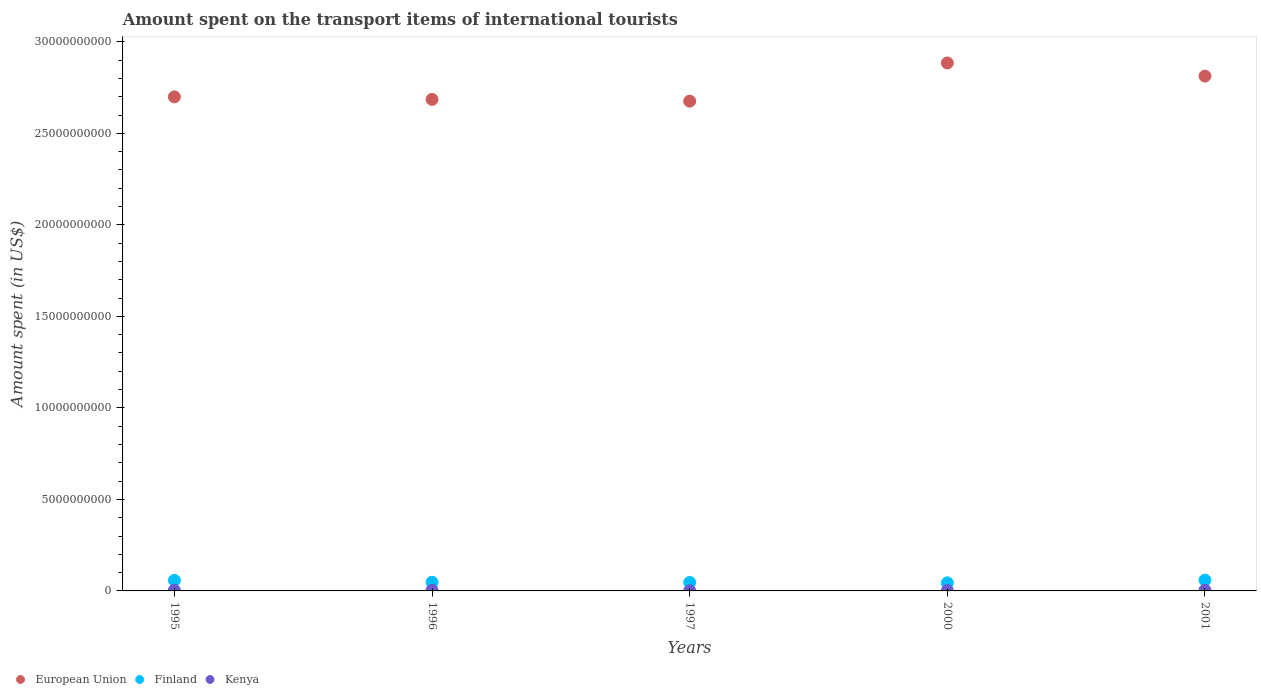How many different coloured dotlines are there?
Make the answer very short. 3. What is the amount spent on the transport items of international tourists in Kenya in 2000?
Offer a terse response. 2.40e+07. Across all years, what is the maximum amount spent on the transport items of international tourists in European Union?
Your answer should be compact. 2.88e+1. Across all years, what is the minimum amount spent on the transport items of international tourists in European Union?
Ensure brevity in your answer.  2.68e+1. In which year was the amount spent on the transport items of international tourists in European Union maximum?
Your answer should be compact. 2000. What is the total amount spent on the transport items of international tourists in Finland in the graph?
Offer a terse response. 2.54e+09. What is the difference between the amount spent on the transport items of international tourists in European Union in 1996 and that in 2000?
Provide a succinct answer. -1.99e+09. What is the difference between the amount spent on the transport items of international tourists in Kenya in 2000 and the amount spent on the transport items of international tourists in European Union in 1996?
Offer a terse response. -2.68e+1. What is the average amount spent on the transport items of international tourists in Kenya per year?
Make the answer very short. 2.90e+07. In the year 1997, what is the difference between the amount spent on the transport items of international tourists in Finland and amount spent on the transport items of international tourists in Kenya?
Provide a succinct answer. 4.54e+08. In how many years, is the amount spent on the transport items of international tourists in Finland greater than 5000000000 US$?
Give a very brief answer. 0. What is the ratio of the amount spent on the transport items of international tourists in Kenya in 1996 to that in 1997?
Offer a terse response. 5.14. Is the difference between the amount spent on the transport items of international tourists in Finland in 1996 and 2001 greater than the difference between the amount spent on the transport items of international tourists in Kenya in 1996 and 2001?
Your answer should be compact. No. What is the difference between the highest and the second highest amount spent on the transport items of international tourists in Finland?
Make the answer very short. 1.50e+07. What is the difference between the highest and the lowest amount spent on the transport items of international tourists in Finland?
Offer a very short reply. 1.49e+08. In how many years, is the amount spent on the transport items of international tourists in European Union greater than the average amount spent on the transport items of international tourists in European Union taken over all years?
Keep it short and to the point. 2. Is the sum of the amount spent on the transport items of international tourists in Kenya in 1996 and 2000 greater than the maximum amount spent on the transport items of international tourists in European Union across all years?
Give a very brief answer. No. Does the graph contain any zero values?
Offer a very short reply. No. What is the title of the graph?
Offer a terse response. Amount spent on the transport items of international tourists. Does "Ghana" appear as one of the legend labels in the graph?
Your answer should be compact. No. What is the label or title of the X-axis?
Your answer should be compact. Years. What is the label or title of the Y-axis?
Provide a succinct answer. Amount spent (in US$). What is the Amount spent (in US$) of European Union in 1995?
Make the answer very short. 2.70e+1. What is the Amount spent (in US$) in Finland in 1995?
Your answer should be compact. 5.75e+08. What is the Amount spent (in US$) in Kenya in 1995?
Your response must be concise. 3.80e+07. What is the Amount spent (in US$) in European Union in 1996?
Your answer should be very brief. 2.69e+1. What is the Amount spent (in US$) of Finland in 1996?
Your answer should be very brief. 4.75e+08. What is the Amount spent (in US$) in Kenya in 1996?
Keep it short and to the point. 3.60e+07. What is the Amount spent (in US$) in European Union in 1997?
Make the answer very short. 2.68e+1. What is the Amount spent (in US$) of Finland in 1997?
Provide a short and direct response. 4.61e+08. What is the Amount spent (in US$) of European Union in 2000?
Offer a very short reply. 2.88e+1. What is the Amount spent (in US$) of Finland in 2000?
Ensure brevity in your answer.  4.41e+08. What is the Amount spent (in US$) of Kenya in 2000?
Make the answer very short. 2.40e+07. What is the Amount spent (in US$) of European Union in 2001?
Your answer should be very brief. 2.81e+1. What is the Amount spent (in US$) of Finland in 2001?
Your answer should be very brief. 5.90e+08. What is the Amount spent (in US$) in Kenya in 2001?
Provide a succinct answer. 4.00e+07. Across all years, what is the maximum Amount spent (in US$) of European Union?
Your answer should be very brief. 2.88e+1. Across all years, what is the maximum Amount spent (in US$) in Finland?
Give a very brief answer. 5.90e+08. Across all years, what is the maximum Amount spent (in US$) in Kenya?
Ensure brevity in your answer.  4.00e+07. Across all years, what is the minimum Amount spent (in US$) of European Union?
Your response must be concise. 2.68e+1. Across all years, what is the minimum Amount spent (in US$) of Finland?
Provide a succinct answer. 4.41e+08. What is the total Amount spent (in US$) in European Union in the graph?
Provide a short and direct response. 1.38e+11. What is the total Amount spent (in US$) in Finland in the graph?
Provide a short and direct response. 2.54e+09. What is the total Amount spent (in US$) of Kenya in the graph?
Keep it short and to the point. 1.45e+08. What is the difference between the Amount spent (in US$) of European Union in 1995 and that in 1996?
Offer a terse response. 1.37e+08. What is the difference between the Amount spent (in US$) of Finland in 1995 and that in 1996?
Provide a short and direct response. 1.00e+08. What is the difference between the Amount spent (in US$) of European Union in 1995 and that in 1997?
Make the answer very short. 2.35e+08. What is the difference between the Amount spent (in US$) in Finland in 1995 and that in 1997?
Provide a succinct answer. 1.14e+08. What is the difference between the Amount spent (in US$) of Kenya in 1995 and that in 1997?
Your answer should be very brief. 3.10e+07. What is the difference between the Amount spent (in US$) in European Union in 1995 and that in 2000?
Provide a short and direct response. -1.85e+09. What is the difference between the Amount spent (in US$) of Finland in 1995 and that in 2000?
Make the answer very short. 1.34e+08. What is the difference between the Amount spent (in US$) of Kenya in 1995 and that in 2000?
Provide a short and direct response. 1.40e+07. What is the difference between the Amount spent (in US$) of European Union in 1995 and that in 2001?
Give a very brief answer. -1.13e+09. What is the difference between the Amount spent (in US$) of Finland in 1995 and that in 2001?
Provide a short and direct response. -1.50e+07. What is the difference between the Amount spent (in US$) of Kenya in 1995 and that in 2001?
Keep it short and to the point. -2.00e+06. What is the difference between the Amount spent (in US$) of European Union in 1996 and that in 1997?
Provide a succinct answer. 9.81e+07. What is the difference between the Amount spent (in US$) of Finland in 1996 and that in 1997?
Provide a succinct answer. 1.40e+07. What is the difference between the Amount spent (in US$) of Kenya in 1996 and that in 1997?
Your answer should be very brief. 2.90e+07. What is the difference between the Amount spent (in US$) in European Union in 1996 and that in 2000?
Your answer should be very brief. -1.99e+09. What is the difference between the Amount spent (in US$) of Finland in 1996 and that in 2000?
Your answer should be very brief. 3.40e+07. What is the difference between the Amount spent (in US$) in European Union in 1996 and that in 2001?
Provide a succinct answer. -1.27e+09. What is the difference between the Amount spent (in US$) in Finland in 1996 and that in 2001?
Provide a succinct answer. -1.15e+08. What is the difference between the Amount spent (in US$) in Kenya in 1996 and that in 2001?
Provide a succinct answer. -4.00e+06. What is the difference between the Amount spent (in US$) of European Union in 1997 and that in 2000?
Offer a terse response. -2.09e+09. What is the difference between the Amount spent (in US$) of Kenya in 1997 and that in 2000?
Offer a terse response. -1.70e+07. What is the difference between the Amount spent (in US$) in European Union in 1997 and that in 2001?
Offer a terse response. -1.37e+09. What is the difference between the Amount spent (in US$) in Finland in 1997 and that in 2001?
Your answer should be compact. -1.29e+08. What is the difference between the Amount spent (in US$) in Kenya in 1997 and that in 2001?
Provide a short and direct response. -3.30e+07. What is the difference between the Amount spent (in US$) of European Union in 2000 and that in 2001?
Ensure brevity in your answer.  7.18e+08. What is the difference between the Amount spent (in US$) of Finland in 2000 and that in 2001?
Keep it short and to the point. -1.49e+08. What is the difference between the Amount spent (in US$) in Kenya in 2000 and that in 2001?
Make the answer very short. -1.60e+07. What is the difference between the Amount spent (in US$) of European Union in 1995 and the Amount spent (in US$) of Finland in 1996?
Your response must be concise. 2.65e+1. What is the difference between the Amount spent (in US$) of European Union in 1995 and the Amount spent (in US$) of Kenya in 1996?
Provide a succinct answer. 2.70e+1. What is the difference between the Amount spent (in US$) in Finland in 1995 and the Amount spent (in US$) in Kenya in 1996?
Offer a terse response. 5.39e+08. What is the difference between the Amount spent (in US$) of European Union in 1995 and the Amount spent (in US$) of Finland in 1997?
Make the answer very short. 2.65e+1. What is the difference between the Amount spent (in US$) in European Union in 1995 and the Amount spent (in US$) in Kenya in 1997?
Your answer should be compact. 2.70e+1. What is the difference between the Amount spent (in US$) of Finland in 1995 and the Amount spent (in US$) of Kenya in 1997?
Keep it short and to the point. 5.68e+08. What is the difference between the Amount spent (in US$) in European Union in 1995 and the Amount spent (in US$) in Finland in 2000?
Give a very brief answer. 2.66e+1. What is the difference between the Amount spent (in US$) of European Union in 1995 and the Amount spent (in US$) of Kenya in 2000?
Give a very brief answer. 2.70e+1. What is the difference between the Amount spent (in US$) in Finland in 1995 and the Amount spent (in US$) in Kenya in 2000?
Your answer should be very brief. 5.51e+08. What is the difference between the Amount spent (in US$) in European Union in 1995 and the Amount spent (in US$) in Finland in 2001?
Keep it short and to the point. 2.64e+1. What is the difference between the Amount spent (in US$) of European Union in 1995 and the Amount spent (in US$) of Kenya in 2001?
Provide a succinct answer. 2.70e+1. What is the difference between the Amount spent (in US$) of Finland in 1995 and the Amount spent (in US$) of Kenya in 2001?
Make the answer very short. 5.35e+08. What is the difference between the Amount spent (in US$) in European Union in 1996 and the Amount spent (in US$) in Finland in 1997?
Make the answer very short. 2.64e+1. What is the difference between the Amount spent (in US$) of European Union in 1996 and the Amount spent (in US$) of Kenya in 1997?
Offer a terse response. 2.68e+1. What is the difference between the Amount spent (in US$) in Finland in 1996 and the Amount spent (in US$) in Kenya in 1997?
Provide a short and direct response. 4.68e+08. What is the difference between the Amount spent (in US$) in European Union in 1996 and the Amount spent (in US$) in Finland in 2000?
Offer a very short reply. 2.64e+1. What is the difference between the Amount spent (in US$) in European Union in 1996 and the Amount spent (in US$) in Kenya in 2000?
Keep it short and to the point. 2.68e+1. What is the difference between the Amount spent (in US$) in Finland in 1996 and the Amount spent (in US$) in Kenya in 2000?
Offer a terse response. 4.51e+08. What is the difference between the Amount spent (in US$) in European Union in 1996 and the Amount spent (in US$) in Finland in 2001?
Give a very brief answer. 2.63e+1. What is the difference between the Amount spent (in US$) in European Union in 1996 and the Amount spent (in US$) in Kenya in 2001?
Your response must be concise. 2.68e+1. What is the difference between the Amount spent (in US$) in Finland in 1996 and the Amount spent (in US$) in Kenya in 2001?
Your answer should be compact. 4.35e+08. What is the difference between the Amount spent (in US$) of European Union in 1997 and the Amount spent (in US$) of Finland in 2000?
Your answer should be compact. 2.63e+1. What is the difference between the Amount spent (in US$) in European Union in 1997 and the Amount spent (in US$) in Kenya in 2000?
Offer a terse response. 2.67e+1. What is the difference between the Amount spent (in US$) of Finland in 1997 and the Amount spent (in US$) of Kenya in 2000?
Ensure brevity in your answer.  4.37e+08. What is the difference between the Amount spent (in US$) of European Union in 1997 and the Amount spent (in US$) of Finland in 2001?
Your response must be concise. 2.62e+1. What is the difference between the Amount spent (in US$) in European Union in 1997 and the Amount spent (in US$) in Kenya in 2001?
Provide a short and direct response. 2.67e+1. What is the difference between the Amount spent (in US$) of Finland in 1997 and the Amount spent (in US$) of Kenya in 2001?
Offer a very short reply. 4.21e+08. What is the difference between the Amount spent (in US$) in European Union in 2000 and the Amount spent (in US$) in Finland in 2001?
Ensure brevity in your answer.  2.83e+1. What is the difference between the Amount spent (in US$) in European Union in 2000 and the Amount spent (in US$) in Kenya in 2001?
Offer a terse response. 2.88e+1. What is the difference between the Amount spent (in US$) in Finland in 2000 and the Amount spent (in US$) in Kenya in 2001?
Offer a very short reply. 4.01e+08. What is the average Amount spent (in US$) in European Union per year?
Provide a succinct answer. 2.75e+1. What is the average Amount spent (in US$) in Finland per year?
Give a very brief answer. 5.08e+08. What is the average Amount spent (in US$) in Kenya per year?
Provide a short and direct response. 2.90e+07. In the year 1995, what is the difference between the Amount spent (in US$) in European Union and Amount spent (in US$) in Finland?
Give a very brief answer. 2.64e+1. In the year 1995, what is the difference between the Amount spent (in US$) of European Union and Amount spent (in US$) of Kenya?
Provide a short and direct response. 2.70e+1. In the year 1995, what is the difference between the Amount spent (in US$) of Finland and Amount spent (in US$) of Kenya?
Give a very brief answer. 5.37e+08. In the year 1996, what is the difference between the Amount spent (in US$) in European Union and Amount spent (in US$) in Finland?
Offer a terse response. 2.64e+1. In the year 1996, what is the difference between the Amount spent (in US$) of European Union and Amount spent (in US$) of Kenya?
Offer a very short reply. 2.68e+1. In the year 1996, what is the difference between the Amount spent (in US$) in Finland and Amount spent (in US$) in Kenya?
Offer a terse response. 4.39e+08. In the year 1997, what is the difference between the Amount spent (in US$) in European Union and Amount spent (in US$) in Finland?
Provide a short and direct response. 2.63e+1. In the year 1997, what is the difference between the Amount spent (in US$) in European Union and Amount spent (in US$) in Kenya?
Your response must be concise. 2.68e+1. In the year 1997, what is the difference between the Amount spent (in US$) in Finland and Amount spent (in US$) in Kenya?
Give a very brief answer. 4.54e+08. In the year 2000, what is the difference between the Amount spent (in US$) of European Union and Amount spent (in US$) of Finland?
Give a very brief answer. 2.84e+1. In the year 2000, what is the difference between the Amount spent (in US$) in European Union and Amount spent (in US$) in Kenya?
Your response must be concise. 2.88e+1. In the year 2000, what is the difference between the Amount spent (in US$) in Finland and Amount spent (in US$) in Kenya?
Keep it short and to the point. 4.17e+08. In the year 2001, what is the difference between the Amount spent (in US$) of European Union and Amount spent (in US$) of Finland?
Provide a short and direct response. 2.75e+1. In the year 2001, what is the difference between the Amount spent (in US$) in European Union and Amount spent (in US$) in Kenya?
Keep it short and to the point. 2.81e+1. In the year 2001, what is the difference between the Amount spent (in US$) of Finland and Amount spent (in US$) of Kenya?
Provide a succinct answer. 5.50e+08. What is the ratio of the Amount spent (in US$) of Finland in 1995 to that in 1996?
Ensure brevity in your answer.  1.21. What is the ratio of the Amount spent (in US$) of Kenya in 1995 to that in 1996?
Your response must be concise. 1.06. What is the ratio of the Amount spent (in US$) in European Union in 1995 to that in 1997?
Offer a terse response. 1.01. What is the ratio of the Amount spent (in US$) of Finland in 1995 to that in 1997?
Provide a succinct answer. 1.25. What is the ratio of the Amount spent (in US$) of Kenya in 1995 to that in 1997?
Provide a short and direct response. 5.43. What is the ratio of the Amount spent (in US$) of European Union in 1995 to that in 2000?
Ensure brevity in your answer.  0.94. What is the ratio of the Amount spent (in US$) of Finland in 1995 to that in 2000?
Ensure brevity in your answer.  1.3. What is the ratio of the Amount spent (in US$) in Kenya in 1995 to that in 2000?
Keep it short and to the point. 1.58. What is the ratio of the Amount spent (in US$) in European Union in 1995 to that in 2001?
Ensure brevity in your answer.  0.96. What is the ratio of the Amount spent (in US$) in Finland in 1995 to that in 2001?
Make the answer very short. 0.97. What is the ratio of the Amount spent (in US$) of Finland in 1996 to that in 1997?
Offer a very short reply. 1.03. What is the ratio of the Amount spent (in US$) in Kenya in 1996 to that in 1997?
Give a very brief answer. 5.14. What is the ratio of the Amount spent (in US$) of European Union in 1996 to that in 2000?
Offer a terse response. 0.93. What is the ratio of the Amount spent (in US$) of Finland in 1996 to that in 2000?
Keep it short and to the point. 1.08. What is the ratio of the Amount spent (in US$) in European Union in 1996 to that in 2001?
Keep it short and to the point. 0.95. What is the ratio of the Amount spent (in US$) in Finland in 1996 to that in 2001?
Provide a succinct answer. 0.81. What is the ratio of the Amount spent (in US$) of Kenya in 1996 to that in 2001?
Provide a succinct answer. 0.9. What is the ratio of the Amount spent (in US$) in European Union in 1997 to that in 2000?
Your response must be concise. 0.93. What is the ratio of the Amount spent (in US$) of Finland in 1997 to that in 2000?
Ensure brevity in your answer.  1.05. What is the ratio of the Amount spent (in US$) of Kenya in 1997 to that in 2000?
Offer a terse response. 0.29. What is the ratio of the Amount spent (in US$) in European Union in 1997 to that in 2001?
Make the answer very short. 0.95. What is the ratio of the Amount spent (in US$) of Finland in 1997 to that in 2001?
Provide a short and direct response. 0.78. What is the ratio of the Amount spent (in US$) of Kenya in 1997 to that in 2001?
Offer a terse response. 0.17. What is the ratio of the Amount spent (in US$) of European Union in 2000 to that in 2001?
Your response must be concise. 1.03. What is the ratio of the Amount spent (in US$) of Finland in 2000 to that in 2001?
Your answer should be very brief. 0.75. What is the ratio of the Amount spent (in US$) in Kenya in 2000 to that in 2001?
Keep it short and to the point. 0.6. What is the difference between the highest and the second highest Amount spent (in US$) in European Union?
Your answer should be compact. 7.18e+08. What is the difference between the highest and the second highest Amount spent (in US$) of Finland?
Make the answer very short. 1.50e+07. What is the difference between the highest and the second highest Amount spent (in US$) in Kenya?
Give a very brief answer. 2.00e+06. What is the difference between the highest and the lowest Amount spent (in US$) in European Union?
Offer a terse response. 2.09e+09. What is the difference between the highest and the lowest Amount spent (in US$) in Finland?
Your response must be concise. 1.49e+08. What is the difference between the highest and the lowest Amount spent (in US$) in Kenya?
Ensure brevity in your answer.  3.30e+07. 